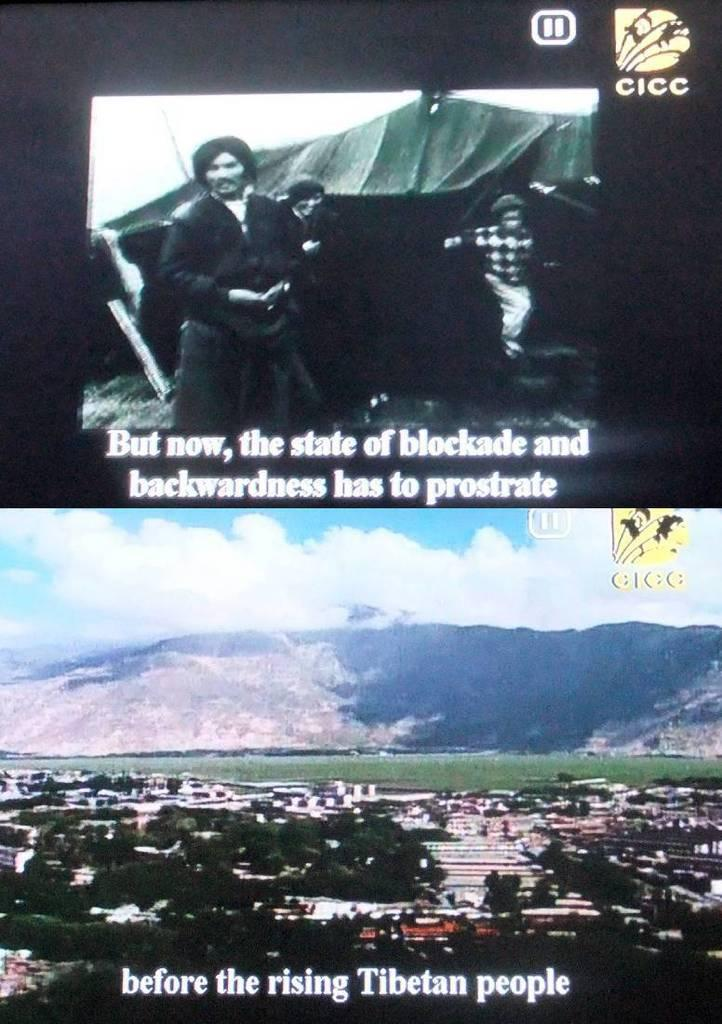<image>
Describe the image concisely. Several men are shown as well as a mountain and the logo CICC. 